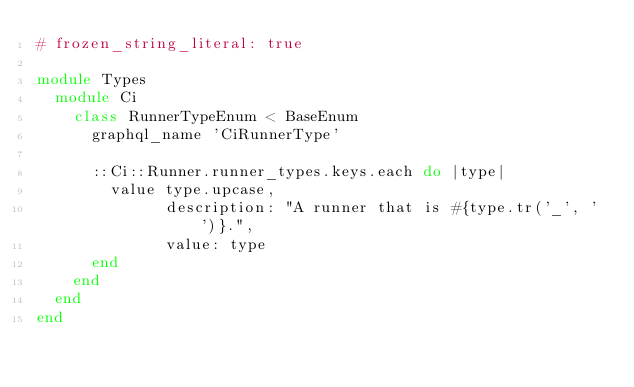Convert code to text. <code><loc_0><loc_0><loc_500><loc_500><_Ruby_># frozen_string_literal: true

module Types
  module Ci
    class RunnerTypeEnum < BaseEnum
      graphql_name 'CiRunnerType'

      ::Ci::Runner.runner_types.keys.each do |type|
        value type.upcase,
              description: "A runner that is #{type.tr('_', ' ')}.",
              value: type
      end
    end
  end
end
</code> 